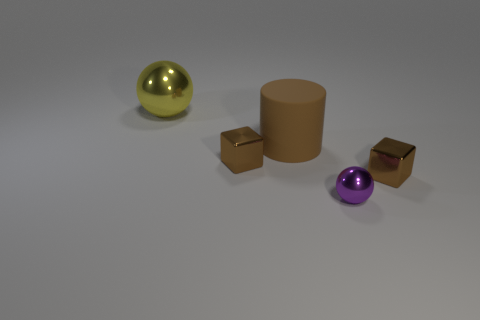Add 3 cyan objects. How many objects exist? 8 Subtract all spheres. How many objects are left? 3 Add 2 metallic objects. How many metallic objects are left? 6 Add 2 large yellow shiny objects. How many large yellow shiny objects exist? 3 Subtract 1 brown cubes. How many objects are left? 4 Subtract all brown matte objects. Subtract all small brown shiny blocks. How many objects are left? 2 